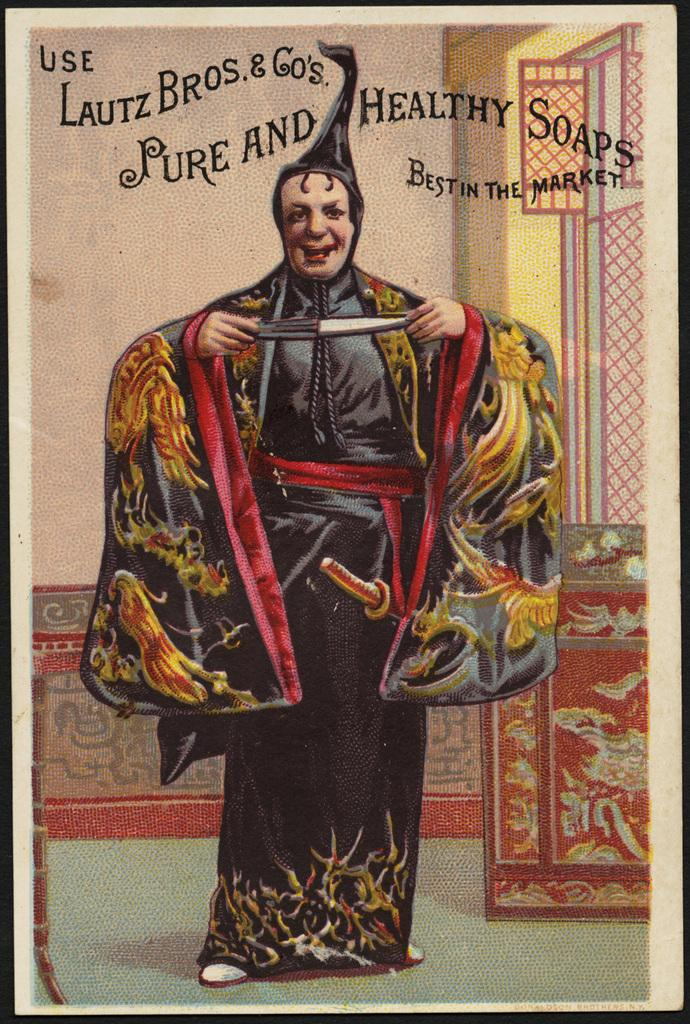What type of image is being described? The image is a poster. What is the person in the poster doing? The person is holding a knife in the poster. Is there any text on the poster? Yes, there is text written on the poster. How many divisions can be seen on the tongue in the poster? There is no tongue present in the poster, and therefore no divisions can be seen on it. 